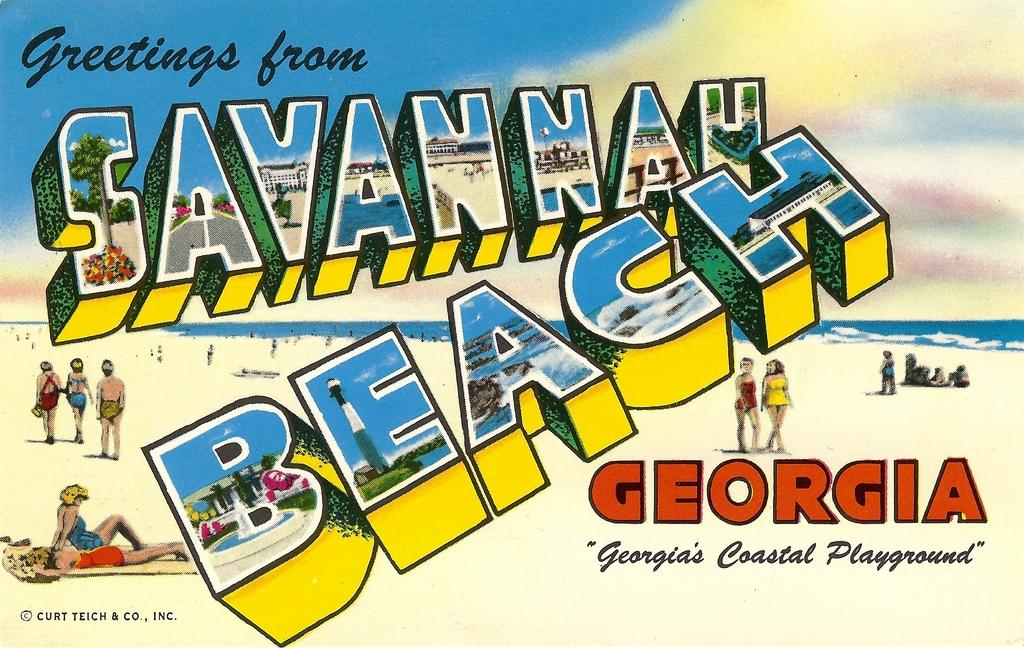<image>
Present a compact description of the photo's key features. A postcard for Savannah Beach, Georgia, known as Georgia's coastal playground. 